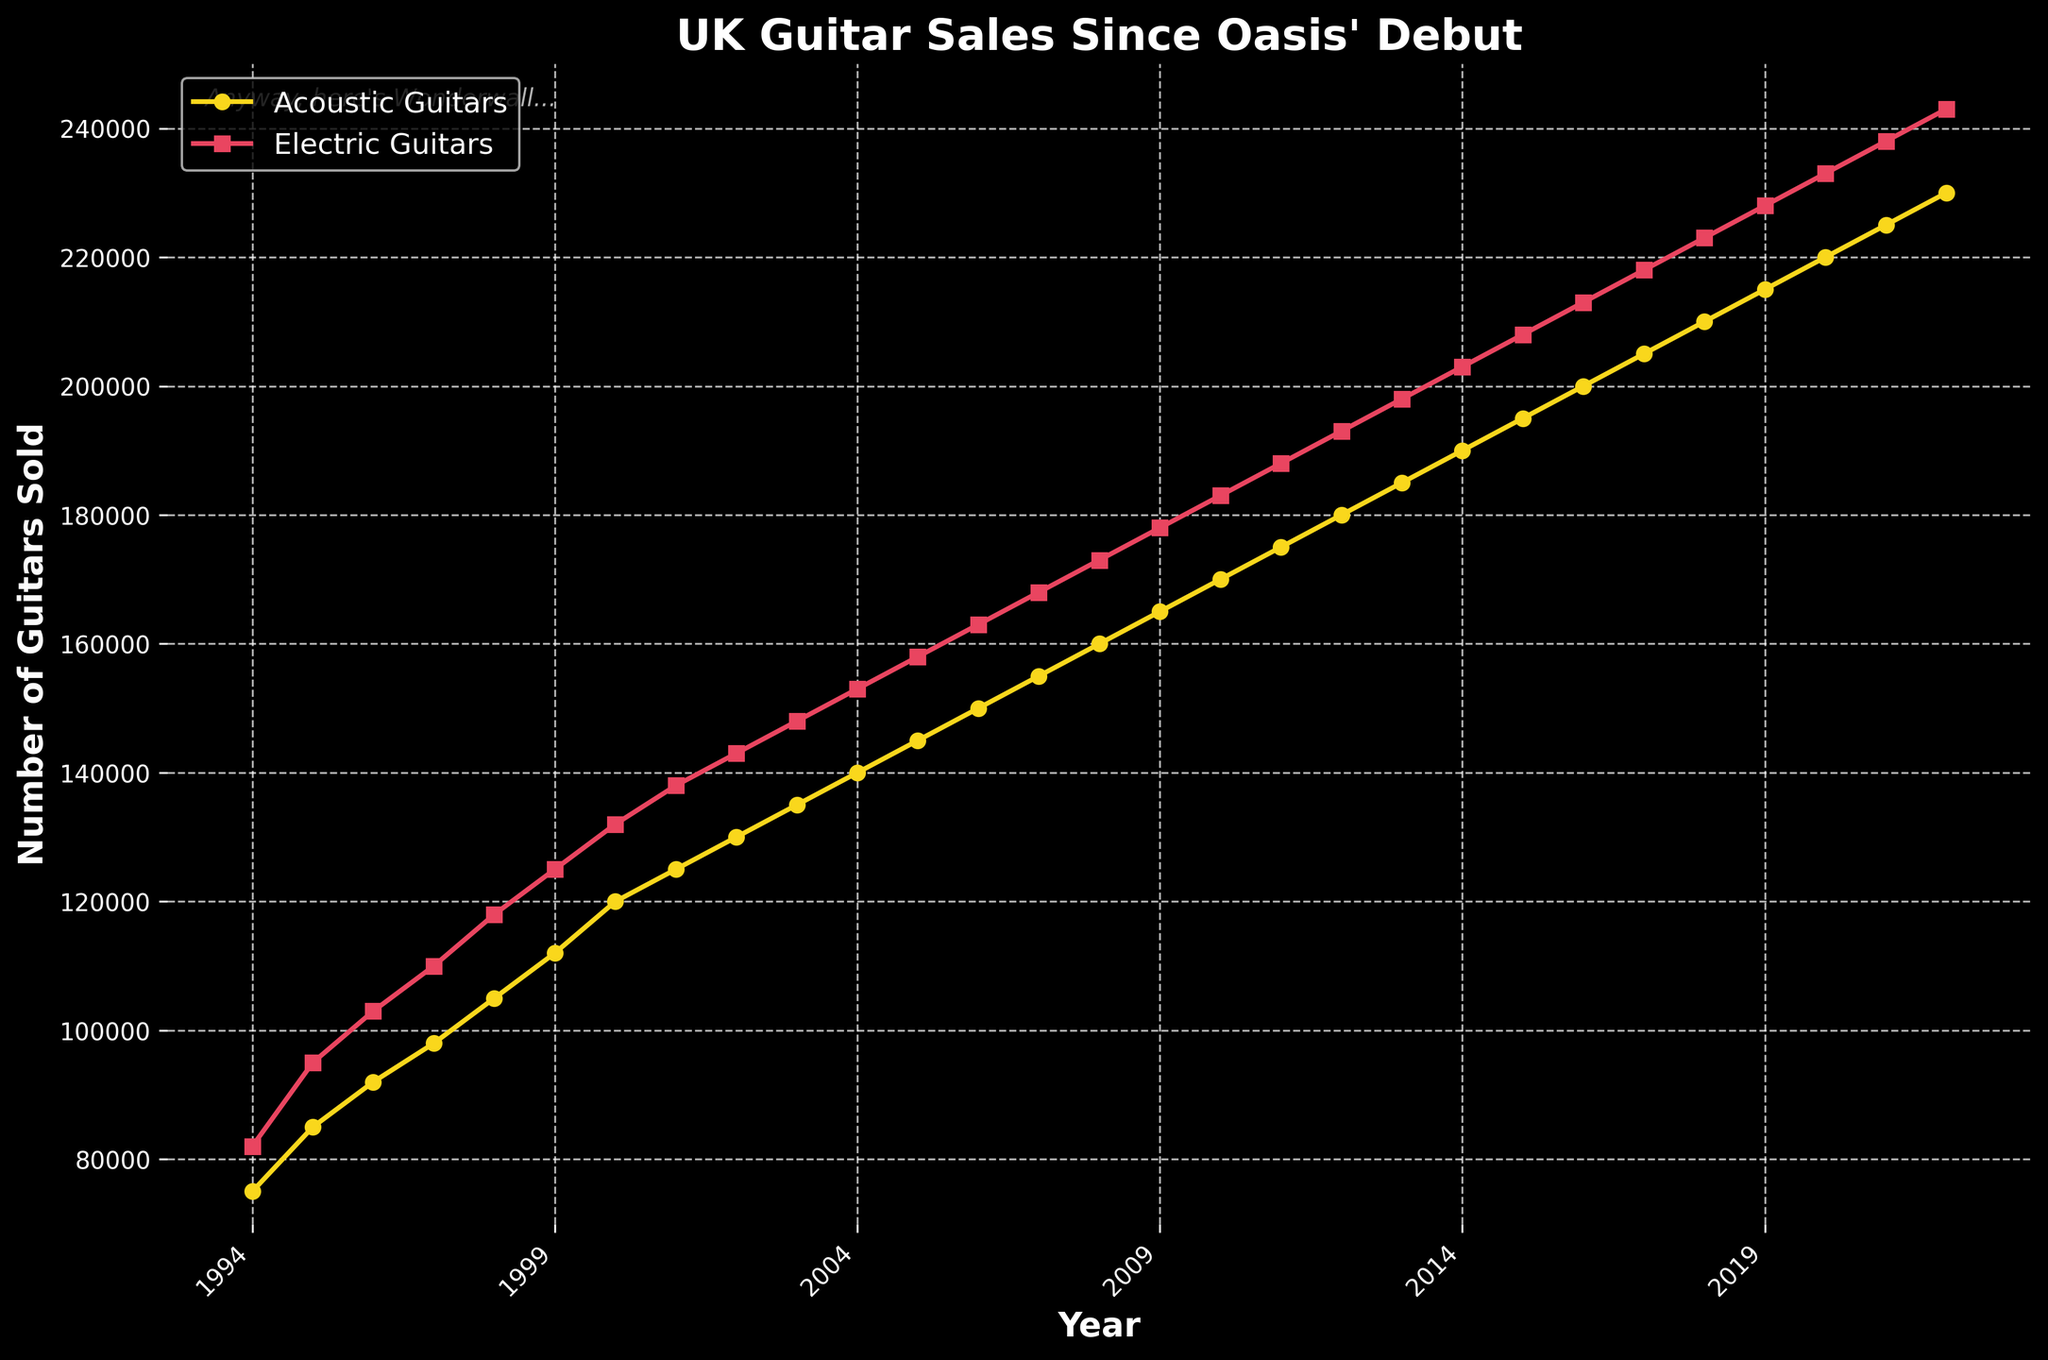What has been the overall trend in sales of acoustic guitars from 1994 to 2022? The sales of acoustic guitars have steadily increased each year from 75,000 in 1994 to 230,000 in 2022. This indicates a consistent rise in the popularity of acoustic guitars over the years.
Answer: Steady increase Which type of guitar had the highest sales in the year 2000? In the year 2000, the number of electric guitars sold was 132,000, while the number of acoustic guitars sold was 120,000. Therefore, electric guitars had higher sales in that year.
Answer: Electric guitars In which year did acoustic guitar sales first exceed 100,000 units? By examining the figure, it's clear that acoustic guitar sales reach 105,000 units in 1998, marking the first year they exceeded 100,000 units.
Answer: 1998 How many more electric guitars were sold than acoustic guitars in 2022? From the figure, electric guitar sales in 2022 were 243,000, and acoustic guitar sales were 230,000. The difference is 243,000 - 230,000 = 13,000.
Answer: 13,000 What is the average number of electric guitars sold from 1994 to 1999? Summing the sales figures for electric guitars from 1994 to 1999 gives 82000 + 95000 + 103000 + 110000 + 118000 + 125000 = 633000. Dividing by 6 gives an average of 633000 / 6 = 105500.
Answer: 105,500 Comparing 1997 and 2007, how much did electric guitar sales grow? Electric guitar sales in 1997 were 110,000 and in 2007 were 168,000. The growth is 168,000 - 110,000 = 58,000.
Answer: 58,000 What can you observe about the sales trends of both guitar types between 1994 and 2022? Both acoustic and electric guitar sales show a steady increase over the years. Acoustic guitar sales started at 75,000 and increased to 230,000, while electric guitar sales started at 82,000 and rose to 243,000.
Answer: Steady increase for both Which year showed the highest year-over-year increase in electric guitar sales? By examining the figure, the largest jump in electric guitar sales appears between 1994 (82,000) and 1995 (95,000), which is an increase of 13,000 units.
Answer: 1995 How much higher were acoustic guitar sales compared to electric guitar sales in 1994? In 1994, 75,000 acoustic guitars were sold, compared to 82,000 electric guitars. Acoustic guitar sales were not higher; electric guitar sales exceeded acoustic guitar sales by 82,000 - 75,000 = 7,000.
Answer: 7,000 (electric guitars were higher) 